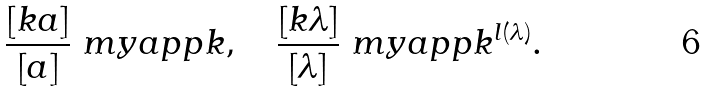Convert formula to latex. <formula><loc_0><loc_0><loc_500><loc_500>\frac { [ k a ] } { [ a ] } \ m y a p p k , \quad \frac { [ k \lambda ] } { [ \lambda ] } \ m y a p p k ^ { l ( \lambda ) } .</formula> 